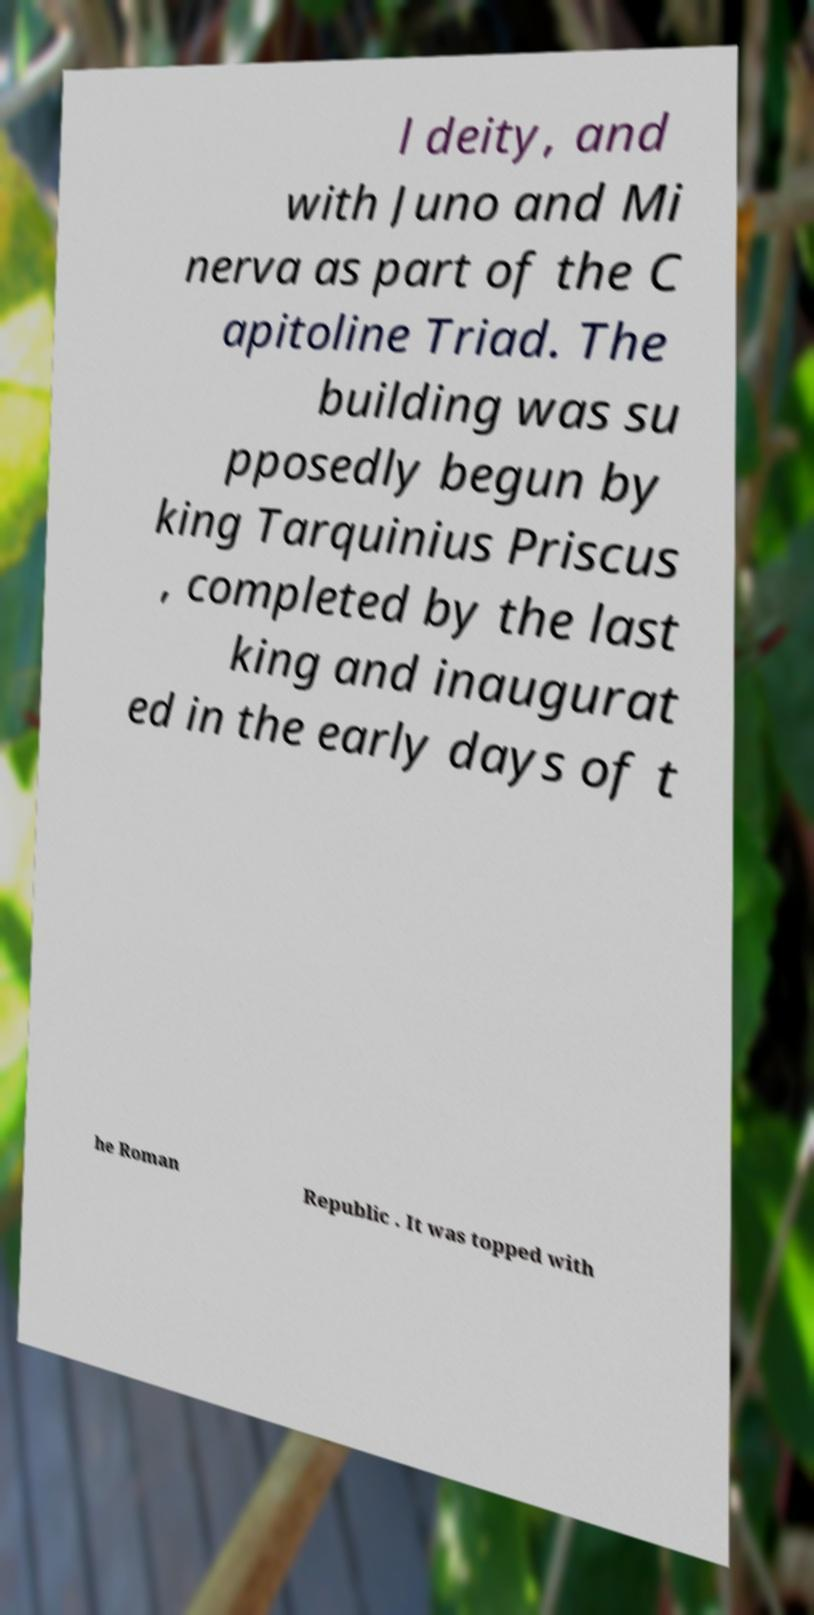Please identify and transcribe the text found in this image. l deity, and with Juno and Mi nerva as part of the C apitoline Triad. The building was su pposedly begun by king Tarquinius Priscus , completed by the last king and inaugurat ed in the early days of t he Roman Republic . It was topped with 